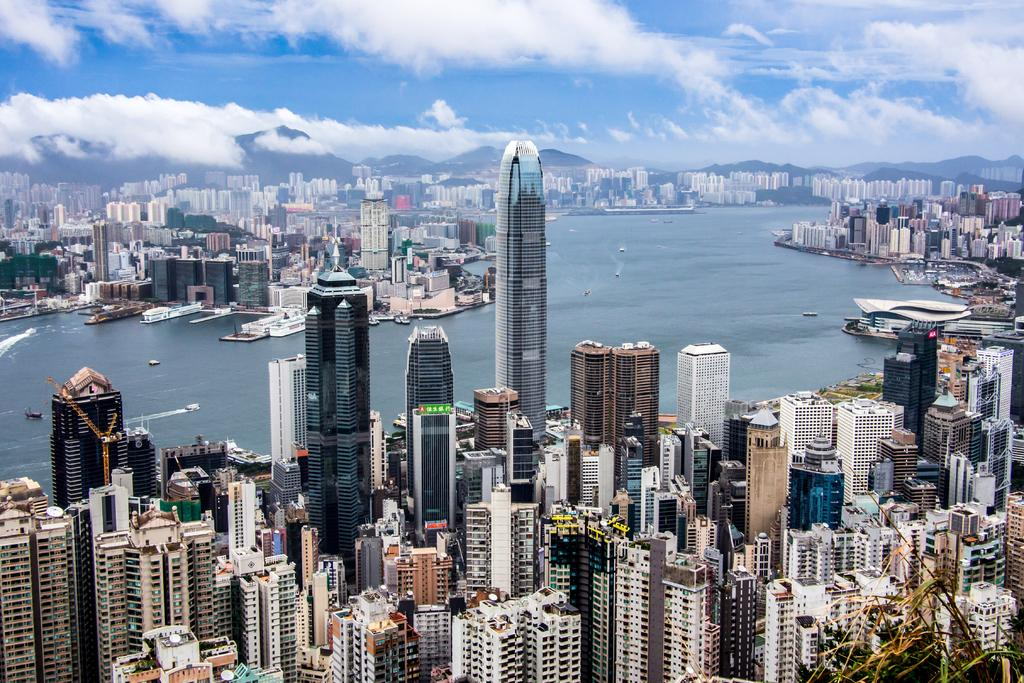What type of structures are present in the image? There is a group of buildings in the image. What natural feature can be seen alongside the buildings? There is water visible in the image. What is floating on the water in the image? There are boats in the water. What type of landscape is visible behind the buildings? There are mountains behind the buildings. What is visible at the top of the image? The sky is visible at the top of the image. Can you see a cow in the image? There is no cow present in the image. Is there a letter being written in the image? There is no letter being written in the image. 